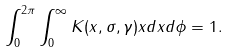Convert formula to latex. <formula><loc_0><loc_0><loc_500><loc_500>\int _ { 0 } ^ { 2 \pi } \int _ { 0 } ^ { \infty } K ( x , \sigma , \gamma ) x d x d \phi = 1 .</formula> 